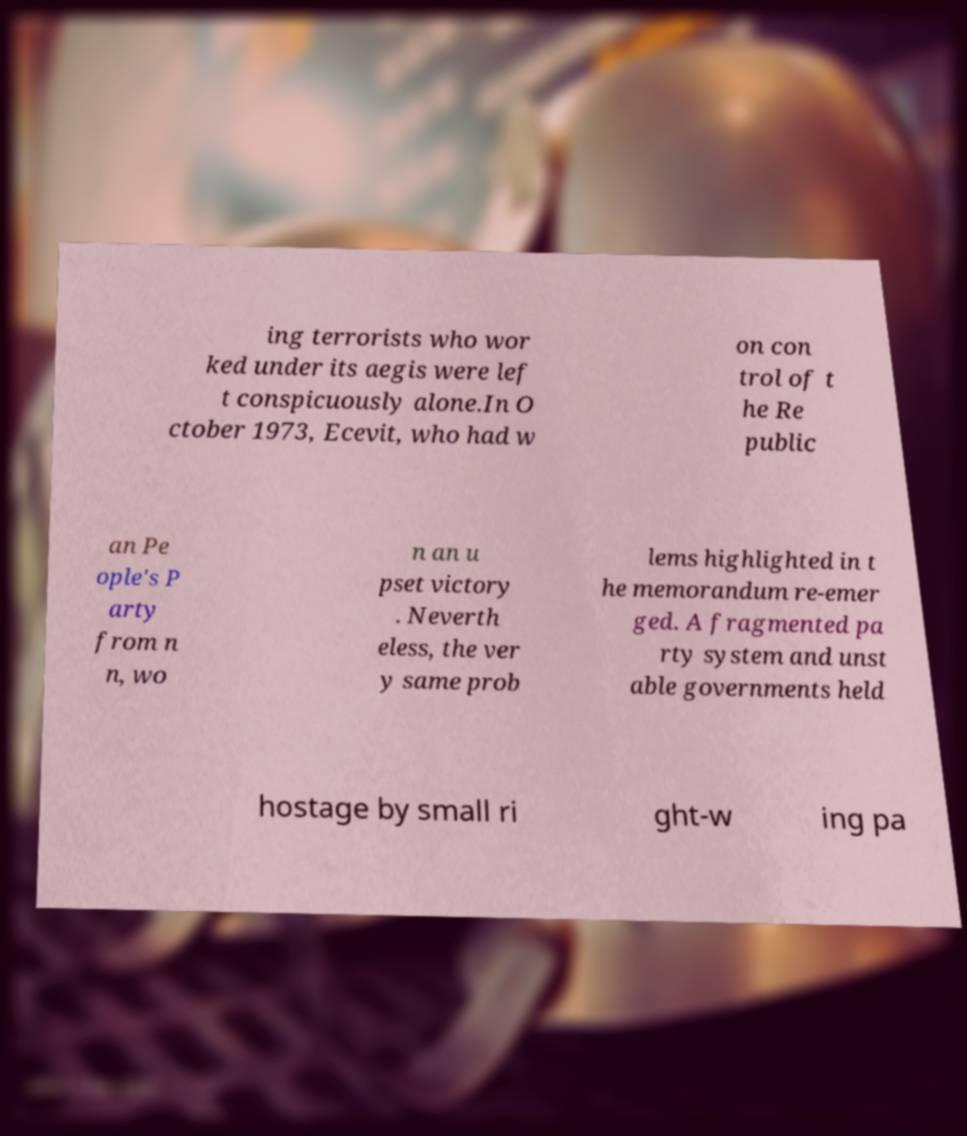Can you read and provide the text displayed in the image?This photo seems to have some interesting text. Can you extract and type it out for me? ing terrorists who wor ked under its aegis were lef t conspicuously alone.In O ctober 1973, Ecevit, who had w on con trol of t he Re public an Pe ople's P arty from n n, wo n an u pset victory . Neverth eless, the ver y same prob lems highlighted in t he memorandum re-emer ged. A fragmented pa rty system and unst able governments held hostage by small ri ght-w ing pa 